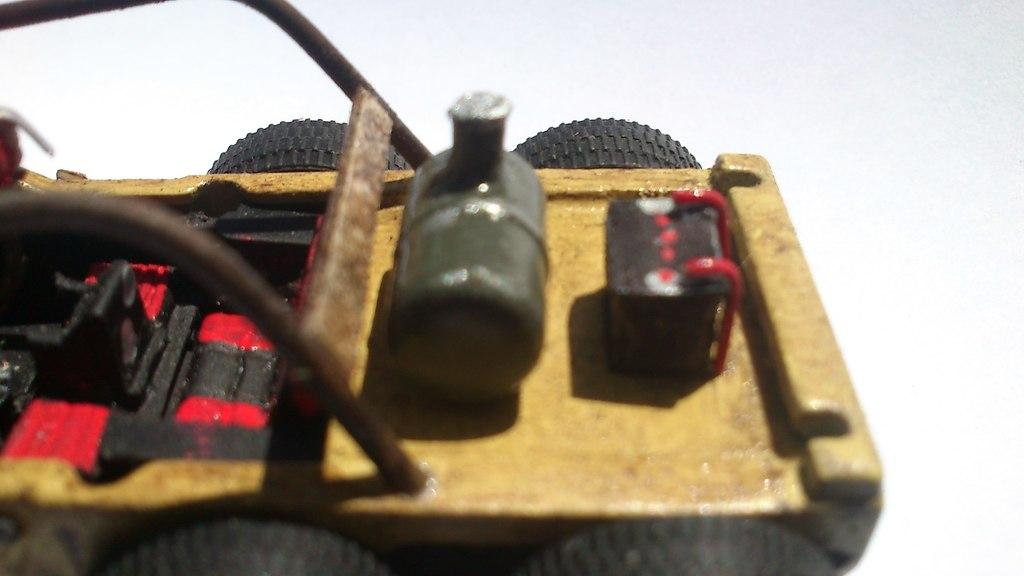What is the main object in the picture? There is a toy car in the picture. What color is the background of the picture? The background of the picture is white. What advice is the toy car giving to the glue in the lunchroom? There is no advice, glue, or lunchroom present in the image; it only features a toy car and a white background. 